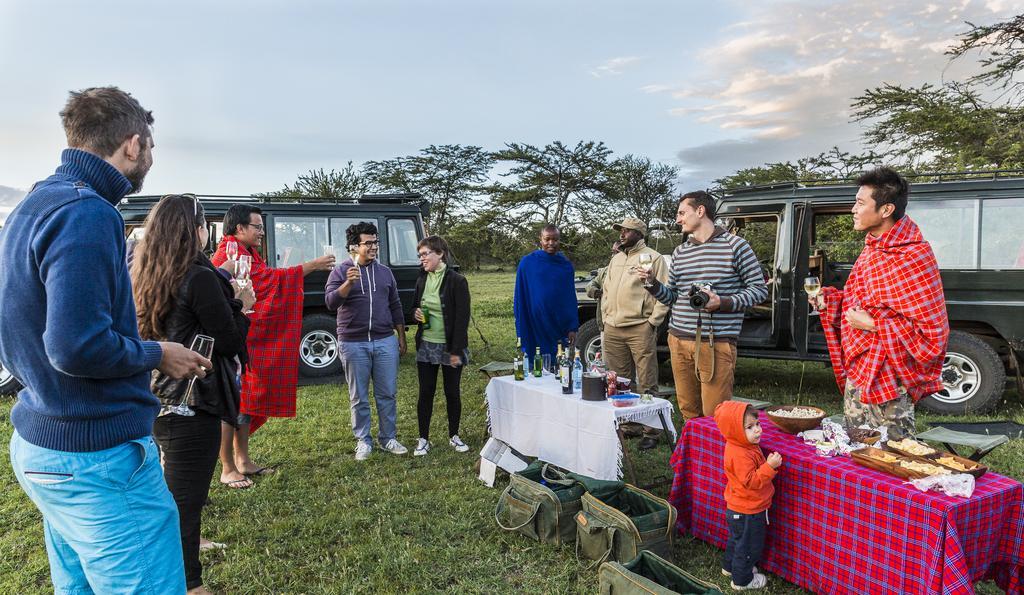How would you summarize this image in a sentence or two? There are people standing and few people holding glasses. We can see bottles, bowl, food, box, clothes and objects on tables. We can see bags on the grass and vehicles. In the background we can see trees and sky with clouds. 